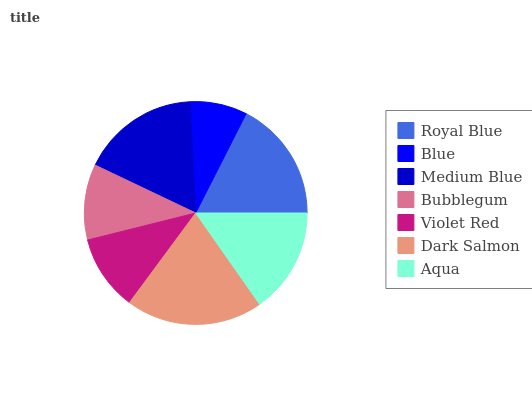Is Blue the minimum?
Answer yes or no. Yes. Is Dark Salmon the maximum?
Answer yes or no. Yes. Is Medium Blue the minimum?
Answer yes or no. No. Is Medium Blue the maximum?
Answer yes or no. No. Is Medium Blue greater than Blue?
Answer yes or no. Yes. Is Blue less than Medium Blue?
Answer yes or no. Yes. Is Blue greater than Medium Blue?
Answer yes or no. No. Is Medium Blue less than Blue?
Answer yes or no. No. Is Aqua the high median?
Answer yes or no. Yes. Is Aqua the low median?
Answer yes or no. Yes. Is Royal Blue the high median?
Answer yes or no. No. Is Dark Salmon the low median?
Answer yes or no. No. 